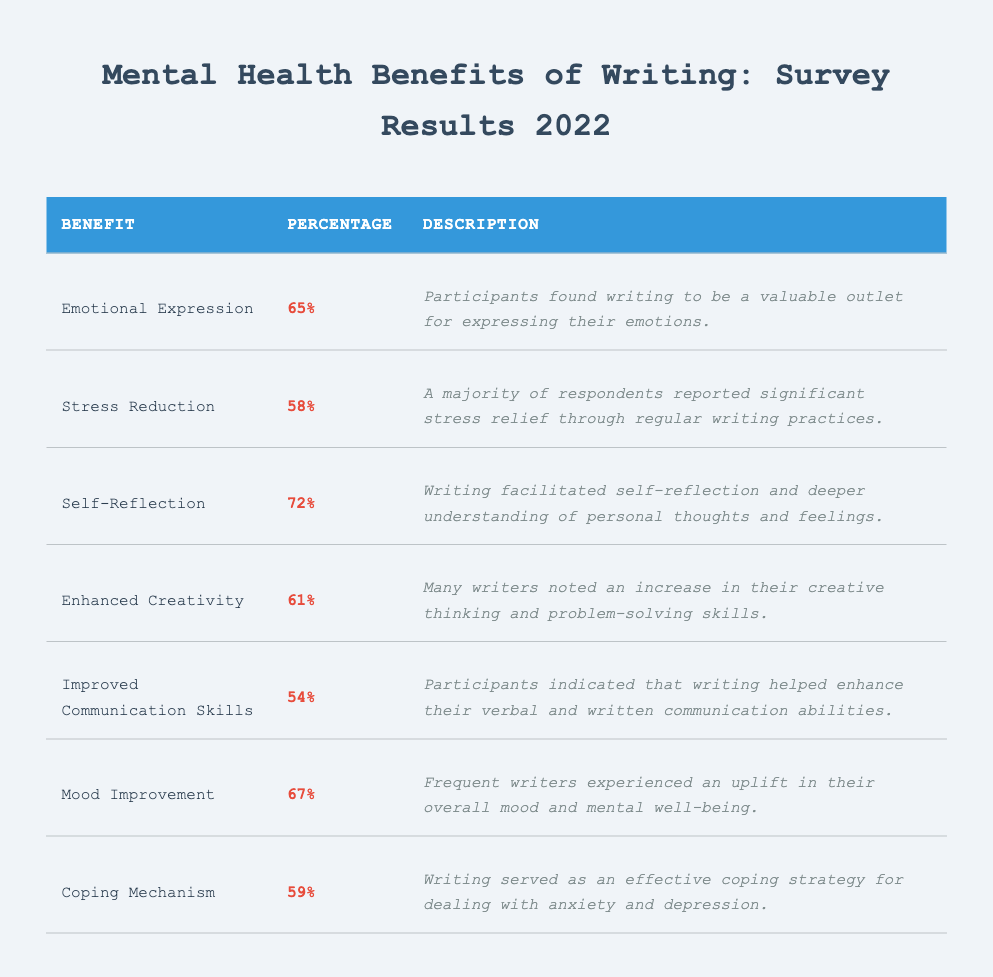What percentage of participants reported writing as a coping mechanism? The table indicates that 59% of participants stated that writing served as an effective coping strategy for dealing with anxiety and depression. Therefore, the answer is taken directly from the "Percentage" column under the "Coping Mechanism" row.
Answer: 59% Which benefit had the highest percentage of agreement among participants? By comparing the percentages in the table, self-reflection had the highest percentage at 72%. This is identified by looking at the "Percentage" column and finding the maximum value.
Answer: 72% What is the difference between the percentage of participants who reported emotional expression and mood improvement benefits? The percentage of emotional expression is 65% and mood improvement is 67%. To find the difference, subtract the lower percentage from the higher: 67 - 65 = 2.
Answer: 2 Did more participants report stress reduction or improved communication skills? The table shows that 58% of participants reported stress reduction, while 54% reported improved communication skills. Since 58% is greater than 54%, we conclude that more participants reported stress reduction.
Answer: Yes What is the average percentage of the reported benefits? To find the average, sum the percentages of all benefits: 65 + 58 + 72 + 61 + 54 + 67 + 59 = 456. There are 7 benefits, so the average is calculated as 456 / 7 = 65.14.
Answer: 65.14 How many benefits had a percentage of 60 or higher? Looking through the table, we find the benefits with percentages of 60 or higher are emotional expression (65%), self-reflection (72%), enhanced creativity (61%), mood improvement (67%), and coping mechanism (59%), which totals to 4 benefits.
Answer: 4 Is the mood improvement percentage higher than the stress reduction percentage? Yes, the mood improvement percentage reported is 67%, which is greater than the stress reduction percentage of 58%. This conclusion is straightforward from the comparison of the two percentages in the table.
Answer: Yes Which benefit appears to have the least reported benefit among respondents? By reviewing the table, "Improved Communication Skills" has the lowest percentage at 54%. Identifying this involves looking for the minimum value in the "Percentage" column.
Answer: 54% 